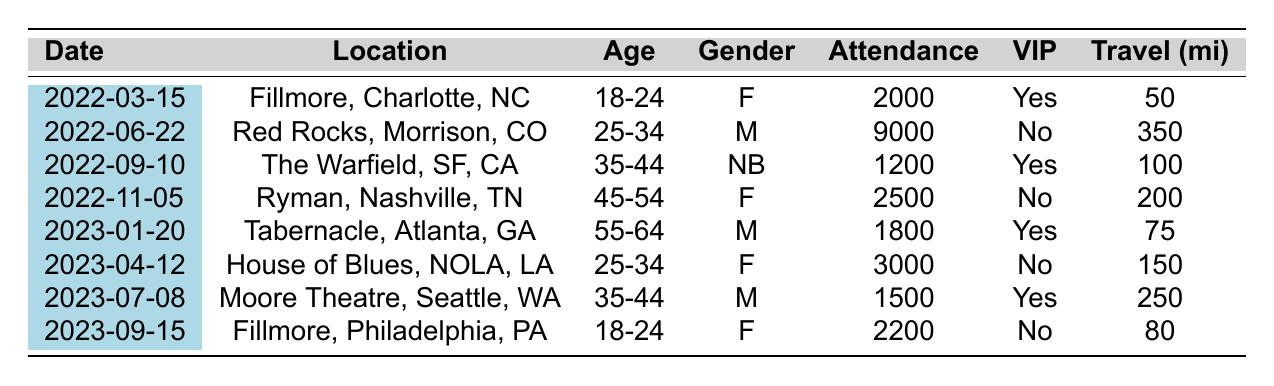What was the total attendance at Gov’t Mule shows in 2022? Summing the attendance for all concerts in 2022: 2000 (Mar) + 9000 (Jun) + 1200 (Sep) + 2500 (Nov) = 14,700.
Answer: 14700 How many concerts were attended by fans aged 25-34? There are two entries for the age group 25-34: one in June 2022 and another in April 2023.
Answer: 2 What is the average travel distance for attendees at the shows? Total travel distances are 50 + 350 + 100 + 200 + 75 + 150 + 250 + 80 = 1255. There are 8 shows, so the average is 1255 / 8 = 156.875.
Answer: 156.875 Did any male attendees purchase VIP packages at the shows? Checking the data, the males in attendance are in positions for June 2022 and January 2023, and only the January 2023 concert shows a VIP purchase. So, yes, at least one male attendee purchased a VIP package.
Answer: Yes Which concert had the highest attendance and what was that number? Looking at the attendance column, the highest number is 9000, which is from the concert on June 22, 2022.
Answer: 9000 What percentage of total concertgoers purchased VIP packages? There are 3 VIP purchases out of 8 concerts leading to 3 tickets out of 14,700 total attendance, giving (3 / 14,700) * 100 = 0.0204%, approximately 0.02%.
Answer: 0.02% How does the total attendance for females compare to the total for males? Summing females gives 2000 (Mar) + 2500 (Nov) + 3000 (Apr) + 2200 (Sep) = 9700. For males: 9000 (Jun) + 1800 (Jan) + 1500 (Jul) = 12300. Thus males outnumber females in total attendance.
Answer: Males have a higher total attendance Which venue had the lowest attendance, and what was the attendance number? The Warfield in San Francisco had the lowest attendance with 1200.
Answer: 1200 What is the difference in attendance between the highest and lowest concert? The highest attendance is 9000 and lowest is 1200, so the difference is 9000 - 1200 = 7800.
Answer: 7800 How many concerts were held in the state of North Carolina? There was one concert in North Carolina, the one on March 15, 2022.
Answer: 1 